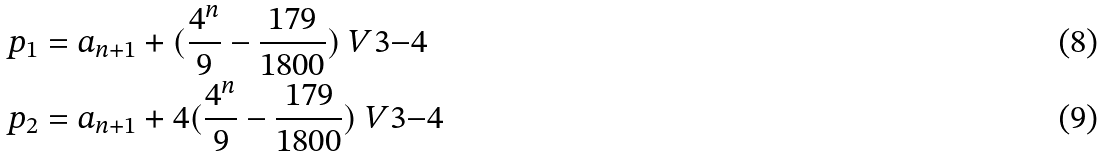<formula> <loc_0><loc_0><loc_500><loc_500>p _ { 1 } & = a _ { n + 1 } + ( \frac { 4 ^ { n } } { 9 } - \frac { 1 7 9 } { 1 8 0 0 } ) \ V { 3 } { - 4 } \\ p _ { 2 } & = a _ { n + 1 } + 4 ( \frac { 4 ^ { n } } { 9 } - \frac { 1 7 9 } { 1 8 0 0 } ) \ V { 3 } { - 4 }</formula> 